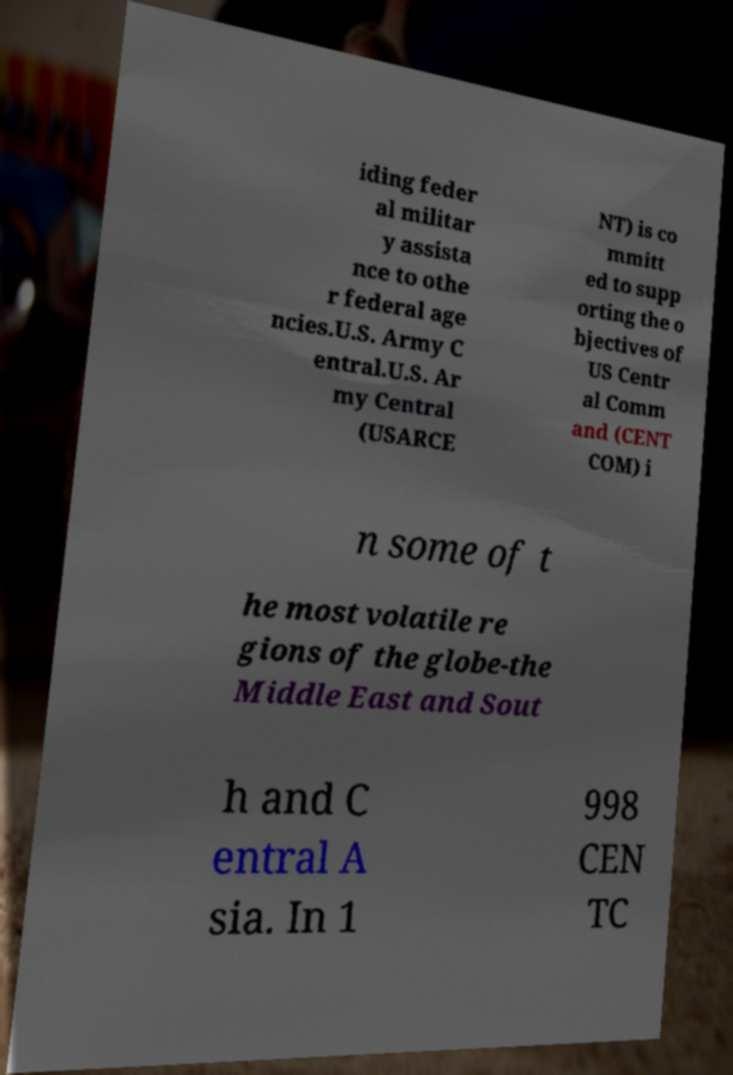Can you accurately transcribe the text from the provided image for me? iding feder al militar y assista nce to othe r federal age ncies.U.S. Army C entral.U.S. Ar my Central (USARCE NT) is co mmitt ed to supp orting the o bjectives of US Centr al Comm and (CENT COM) i n some of t he most volatile re gions of the globe-the Middle East and Sout h and C entral A sia. In 1 998 CEN TC 